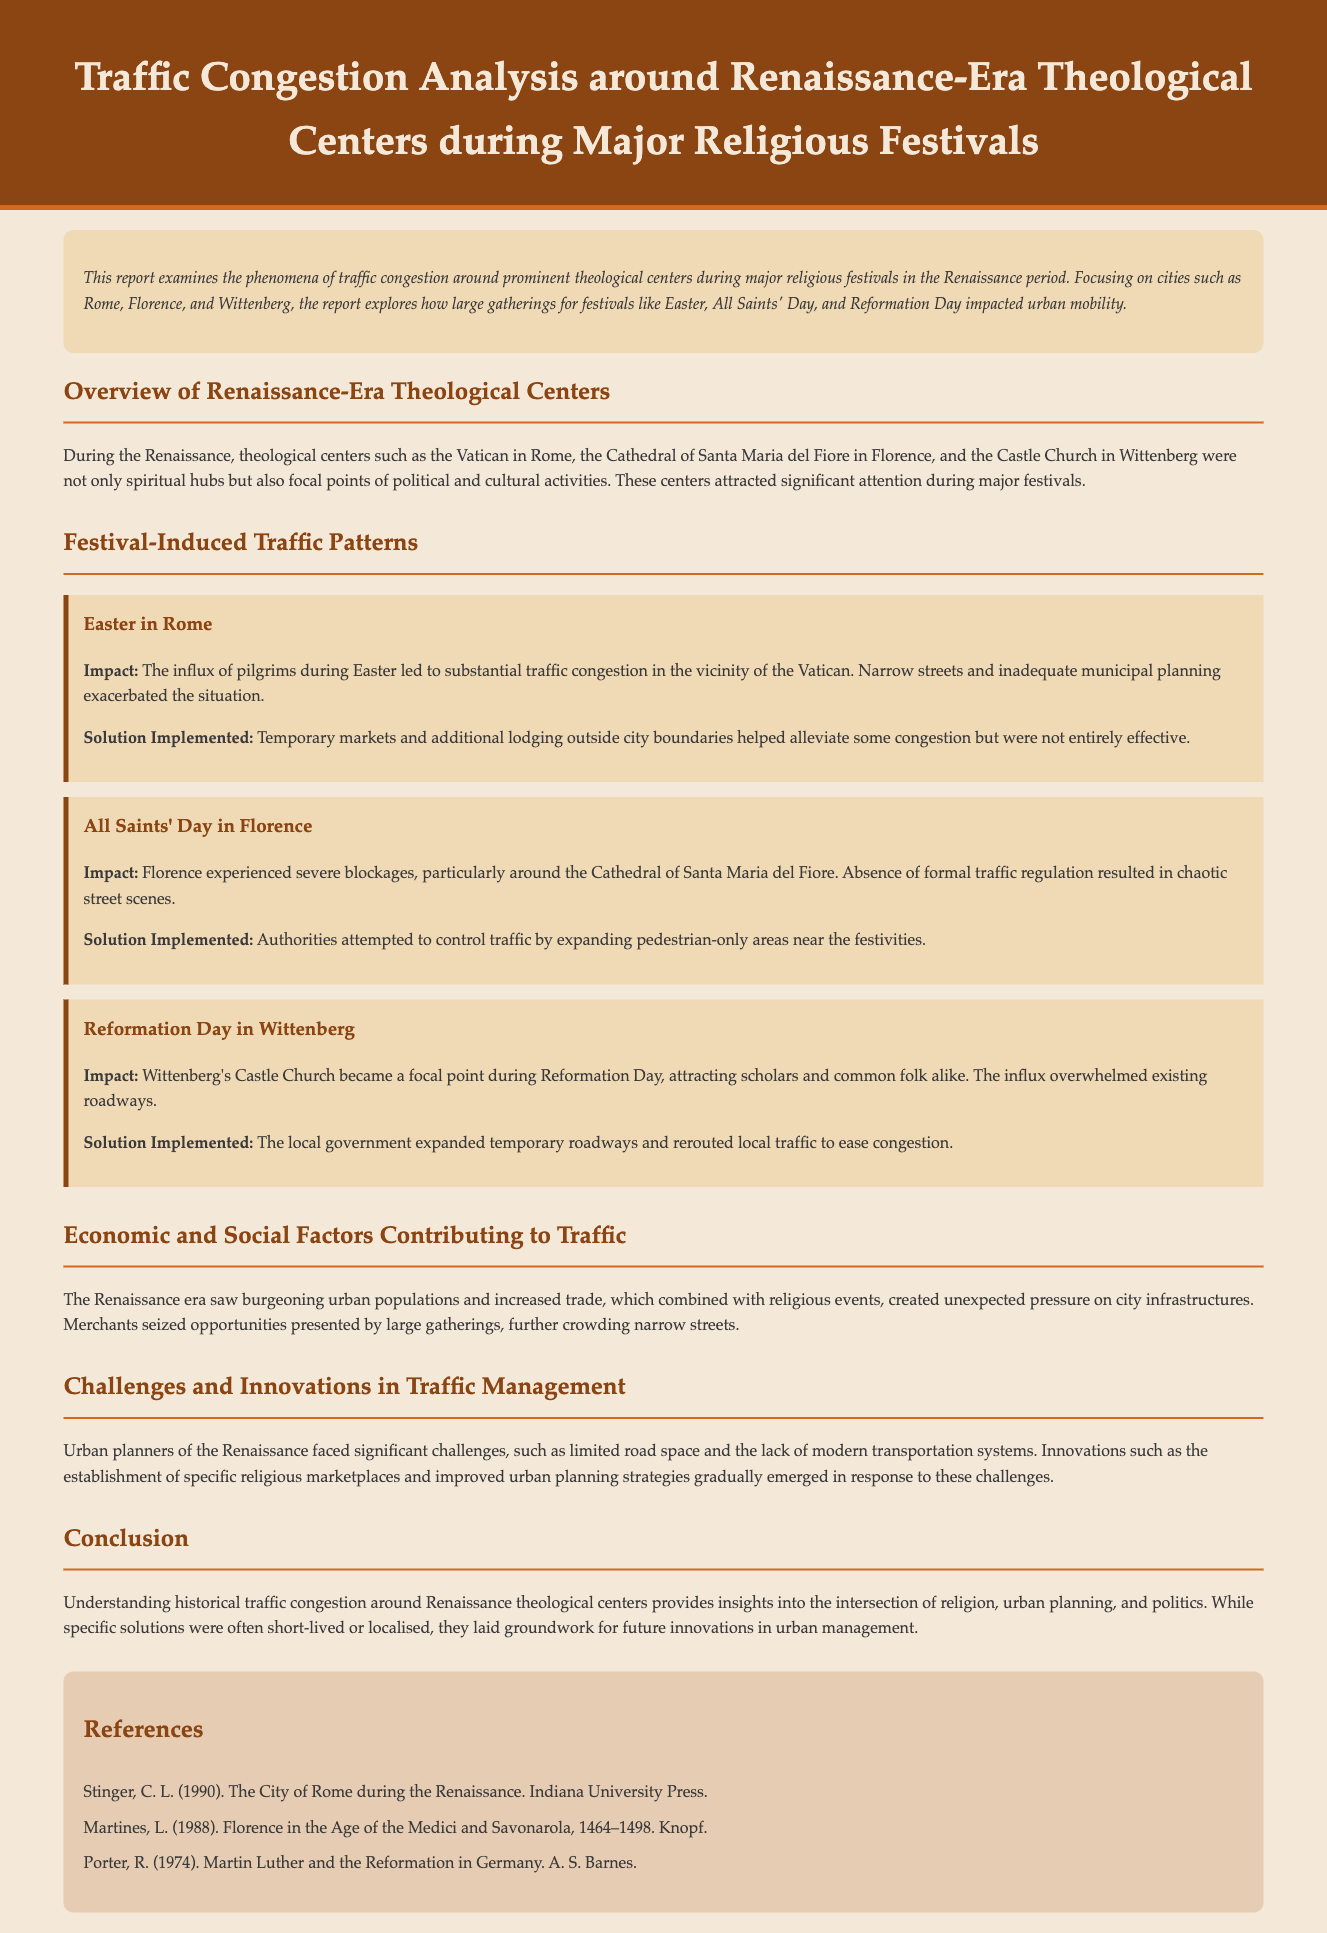What major religious festival led to significant congestion in Rome? The document states that Easter caused substantial traffic congestion in the vicinity of the Vatican.
Answer: Easter What theological center is associated with All Saints' Day? The Cathedral of Santa Maria del Fiore in Florence is highlighted in connection with All Saints' Day traffic congestion.
Answer: Cathedral of Santa Maria del Fiore What solution was attempted to alleviate congestion during All Saints' Day? Authorities attempted to control traffic by expanding pedestrian-only areas near the festivities, as mentioned in the report.
Answer: Expanding pedestrian-only areas What was the impact of the influx of pilgrims during Easter? The influx resulted in substantial traffic congestion, particularly mentioned in the context of the Vatican area.
Answer: Substantial traffic congestion How did Wittenberg's local government respond to Reformation Day congestion? The local government expanded temporary roadways and rerouted local traffic to ease congestion during Reformation Day.
Answer: Expanded temporary roadways Which city experienced severe traffic blockages due to a major festival? Florence is noted for experiencing severe blockages around the Cathedral during All Saints' Day.
Answer: Florence What social factor contributed to traffic congestion during the Renaissance? Increased urban populations and trade are highlighted as contributing factors to the traffic congestion around religious events.
Answer: Increased urban populations and trade What does the report conclude about historical traffic congestion? It provides insights into the intersection of religion, urban planning, and politics regarding traffic management.
Answer: Intersection of religion, urban planning, and politics 